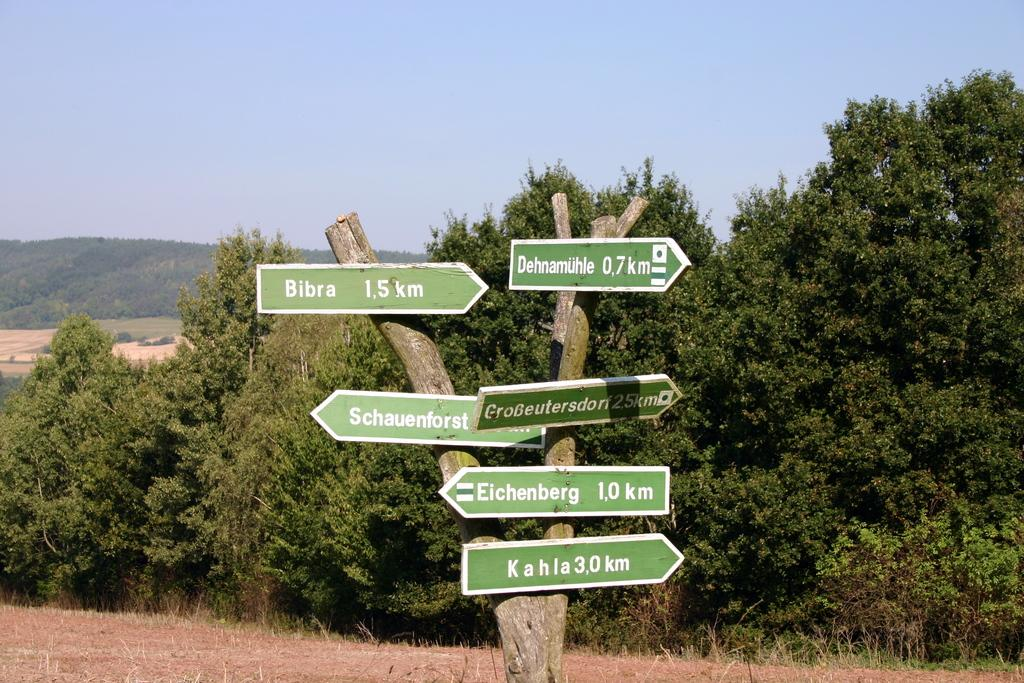<image>
Write a terse but informative summary of the picture. A green sign tells people that Bibra is to the right while Eichenberg is to the left. 